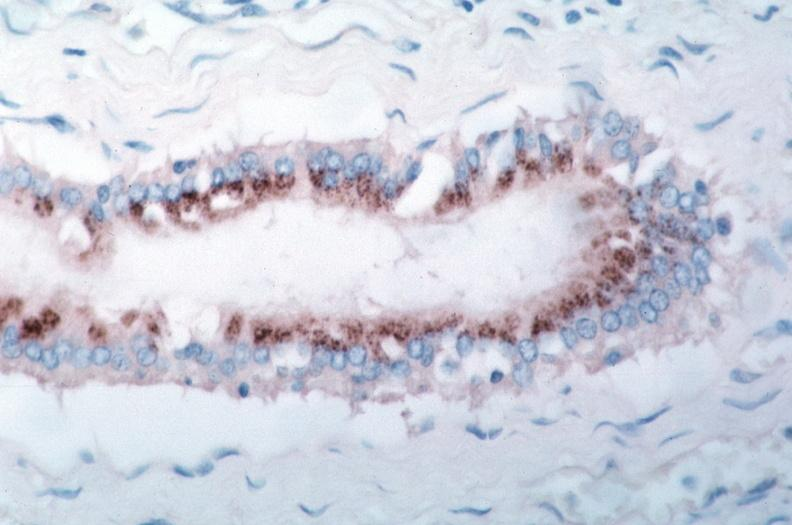does this image show vasculitis?
Answer the question using a single word or phrase. Yes 